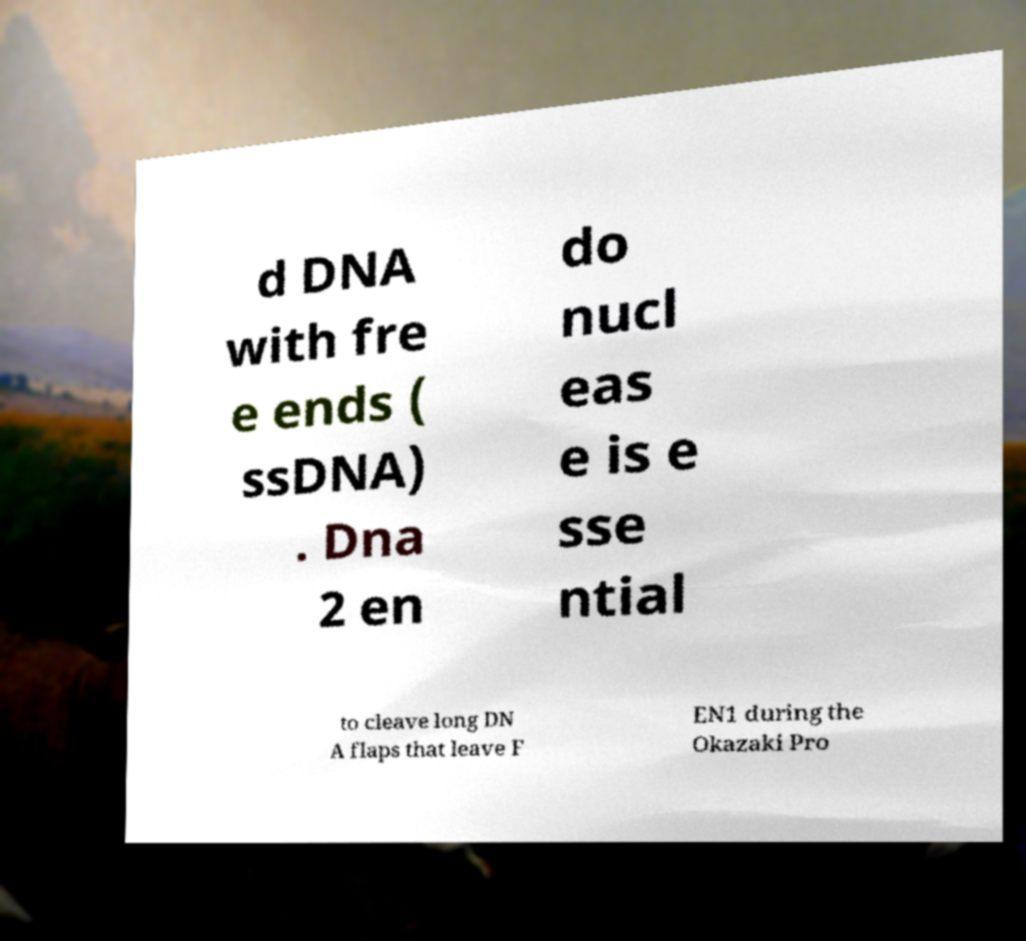What messages or text are displayed in this image? I need them in a readable, typed format. d DNA with fre e ends ( ssDNA) . Dna 2 en do nucl eas e is e sse ntial to cleave long DN A flaps that leave F EN1 during the Okazaki Pro 